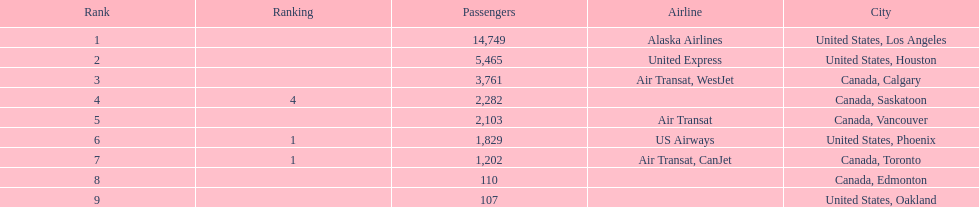Parse the table in full. {'header': ['Rank', 'Ranking', 'Passengers', 'Airline', 'City'], 'rows': [['1', '', '14,749', 'Alaska Airlines', 'United States, Los Angeles'], ['2', '', '5,465', 'United Express', 'United States, Houston'], ['3', '', '3,761', 'Air Transat, WestJet', 'Canada, Calgary'], ['4', '4', '2,282', '', 'Canada, Saskatoon'], ['5', '', '2,103', 'Air Transat', 'Canada, Vancouver'], ['6', '1', '1,829', 'US Airways', 'United States, Phoenix'], ['7', '1', '1,202', 'Air Transat, CanJet', 'Canada, Toronto'], ['8', '', '110', '', 'Canada, Edmonton'], ['9', '', '107', '', 'United States, Oakland']]} How many airlines have a steady ranking? 4. 